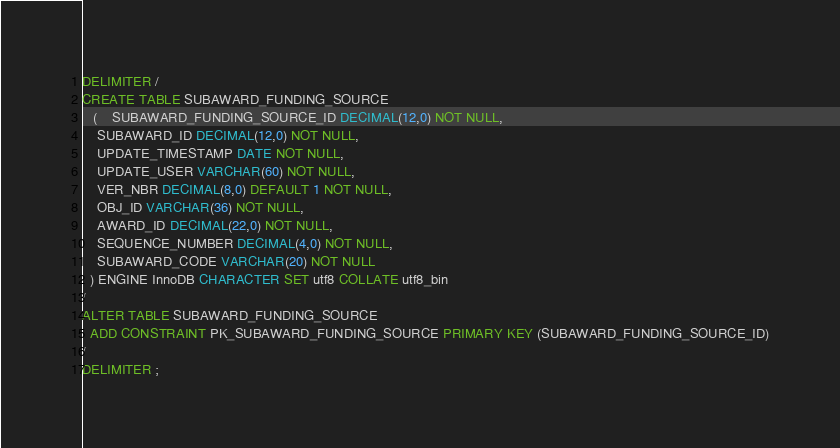Convert code to text. <code><loc_0><loc_0><loc_500><loc_500><_SQL_>DELIMITER /
CREATE TABLE SUBAWARD_FUNDING_SOURCE 
   (	SUBAWARD_FUNDING_SOURCE_ID DECIMAL(12,0) NOT NULL, 
	SUBAWARD_ID DECIMAL(12,0) NOT NULL, 
	UPDATE_TIMESTAMP DATE NOT NULL, 
	UPDATE_USER VARCHAR(60) NOT NULL, 
	VER_NBR DECIMAL(8,0) DEFAULT 1 NOT NULL, 
	OBJ_ID VARCHAR(36) NOT NULL, 
	AWARD_ID DECIMAL(22,0) NOT NULL,
	SEQUENCE_NUMBER DECIMAL(4,0) NOT NULL,
	SUBAWARD_CODE VARCHAR(20) NOT NULL
  ) ENGINE InnoDB CHARACTER SET utf8 COLLATE utf8_bin
/
ALTER TABLE SUBAWARD_FUNDING_SOURCE
  ADD CONSTRAINT PK_SUBAWARD_FUNDING_SOURCE PRIMARY KEY (SUBAWARD_FUNDING_SOURCE_ID)
/
DELIMITER ;
</code> 